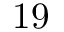Convert formula to latex. <formula><loc_0><loc_0><loc_500><loc_500>1 9</formula> 